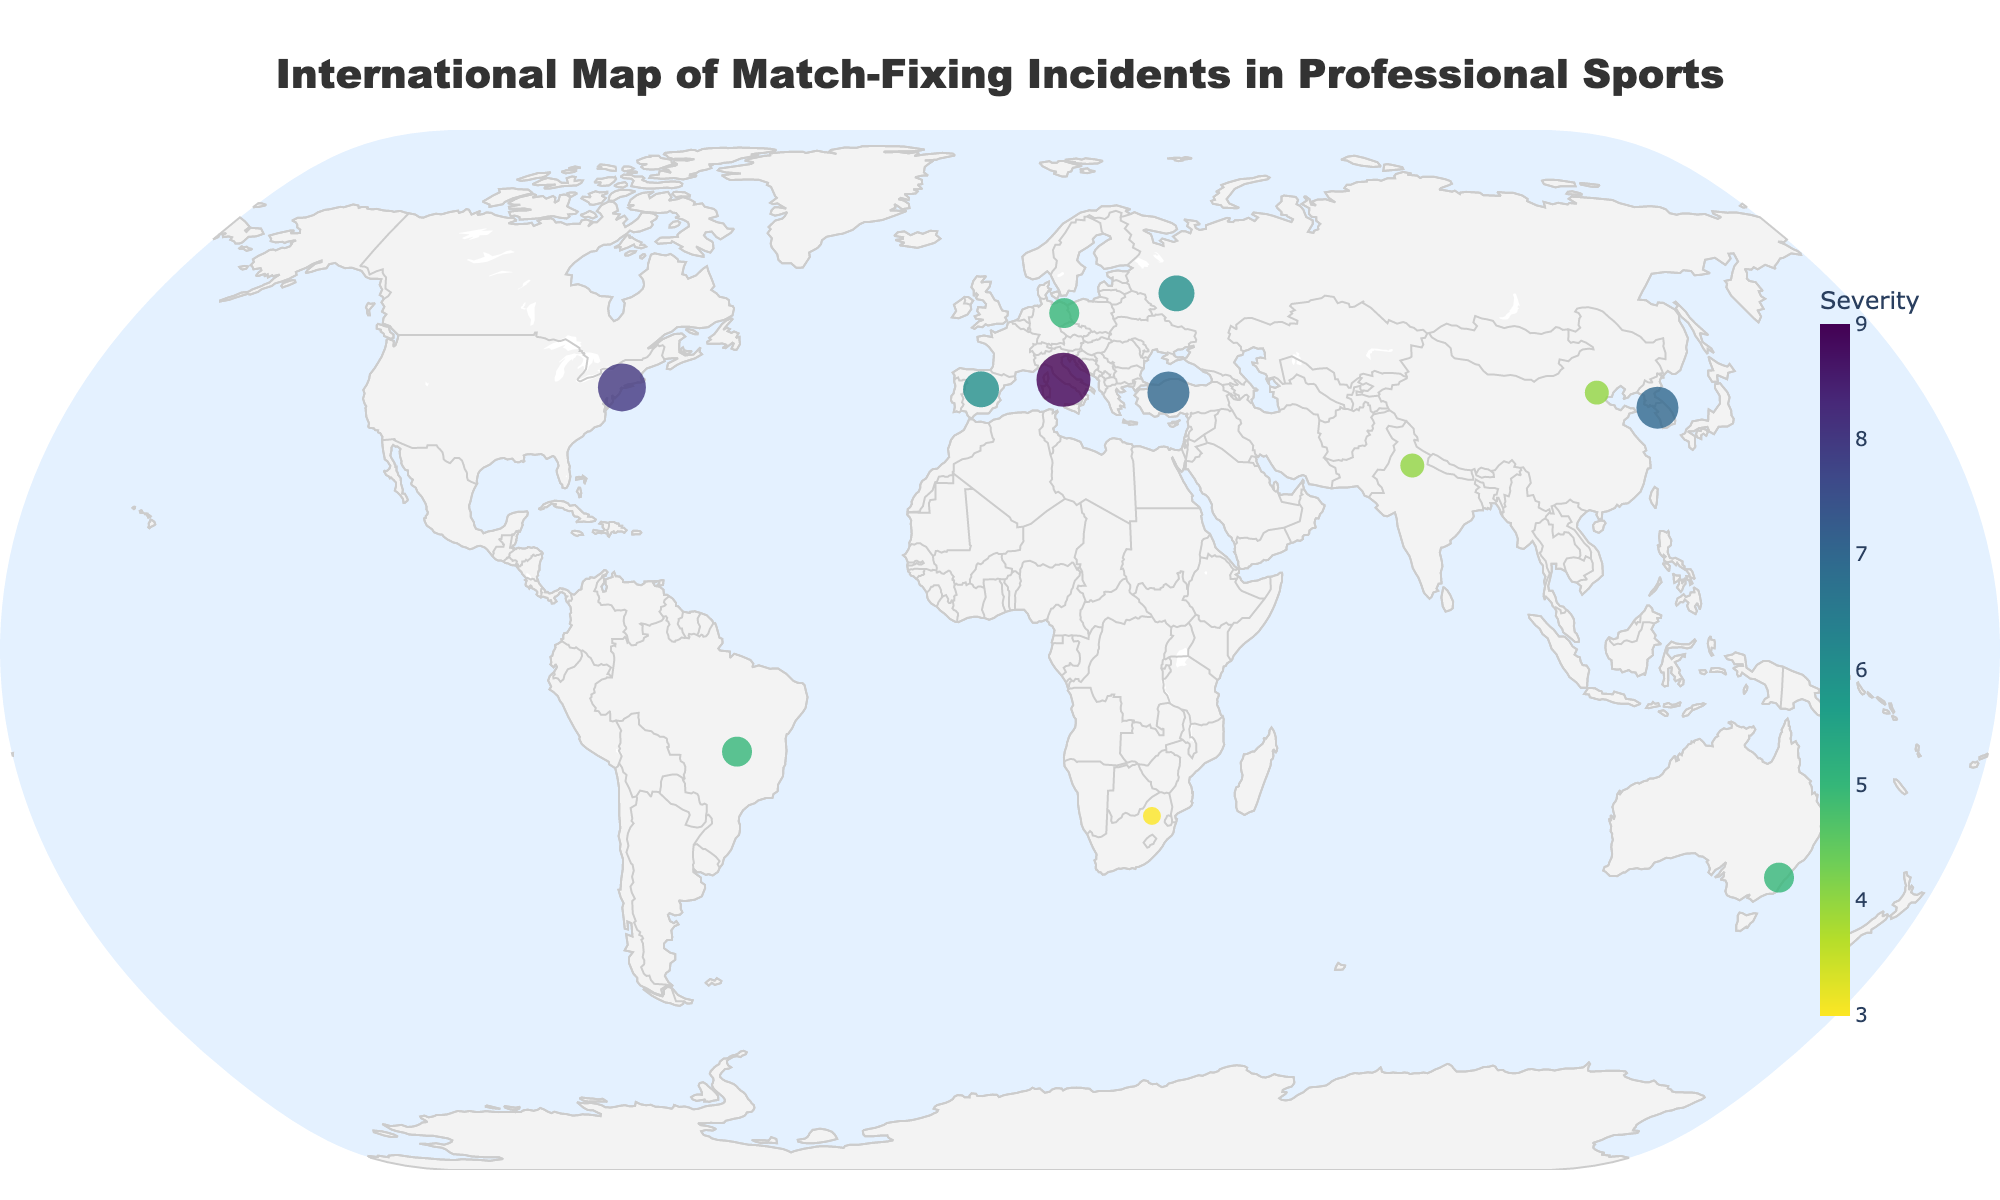Which country has the highest severity incident? By looking at the plot, identify the marker with the largest size and highest color intensity, which represents the highest severity rating. The severity rating is also displayed in the tooltip text when the marker is hovered over.
Answer: Italy What is the total severity of the incidents plotted? Sum the severity ratings for all marked incidents: 9 (Italy) + 7 (South Korea) + 6 (Russia) + 5 (Australia) + 8 (United States) + 4 (China) + 6 (Spain) + 5 (Brazil) + 3 (South Africa) + 4 (India) + 5 (Germany) + 7 (Turkey) = 69
Answer: 69 Which sport has the most severe match-fixing incident? Checking the tooltip text for each marker, identify the sport associated with the highest severity rating of 9, which is displayed on the map for the country Italy.
Answer: Soccer How many incidents have a severity greater than 5? Count the markers that have severity ratings greater than 5: Italy (9), South Korea (7), Russia (6), United States (8), and Turkey (7). This gives us 5 incidents.
Answer: 5 Where did the lowest severity match-fixing incident occur? Locate the smallest marker on the map with the lowest color intensity and check the tooltip text for its location. The severity rating for South Africa is 3, which is the lowest on the map.
Answer: South Africa Which continents have reported incidents? Look at the geographic locations of the markers and determine which continents they are on: Europe (Italy, Spain, Germany, Turkey, Russia), Asia (South Korea, China, India), North America (United States), South America (Brazil), Africa (South Africa), and Australia.
Answer: Europe, Asia, North America, South America, Africa, Australia What is the average severity of the incidents in Europe? Calculate the average of the severity ratings from the incidents in Europe: Italy (9), Spain (6), Germany (5), Turkey (7), and Russia (6). The total is 33 and the number of incidents is 5. The average is 33 / 5 = 6.6
Answer: 6.6 Which two incidents have the same severity and what is that severity? Identify markers with the same color intensity and size on the map or check the tooltip text of each marker. Both Russia and Spain have a severity rating of 6.
Answer: Russia and Spain, 6 